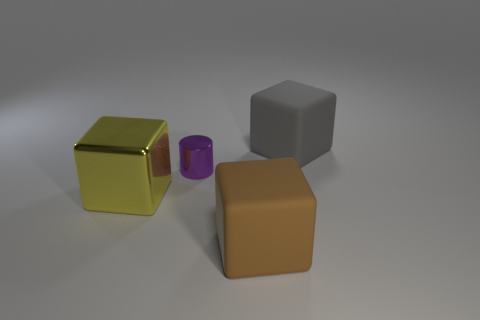Are there any other things that have the same shape as the tiny purple metallic object?
Ensure brevity in your answer.  No. Is the material of the cube behind the large metal cube the same as the brown thing?
Your answer should be compact. Yes. The big matte block left of the big gray cube is what color?
Make the answer very short. Brown. Are there any brown rubber blocks of the same size as the yellow metallic object?
Keep it short and to the point. Yes. There is a brown block that is the same size as the gray thing; what is it made of?
Offer a very short reply. Rubber. There is a gray rubber object; is it the same size as the rubber block in front of the purple cylinder?
Make the answer very short. Yes. There is a thing that is left of the small purple metal cylinder; what is it made of?
Make the answer very short. Metal. Is the number of tiny purple shiny things that are in front of the big yellow thing the same as the number of small metal cylinders?
Make the answer very short. No. Is the yellow thing the same size as the purple metal cylinder?
Your answer should be compact. No. Are there any matte objects behind the matte cube that is in front of the large object behind the big yellow block?
Your response must be concise. Yes. 